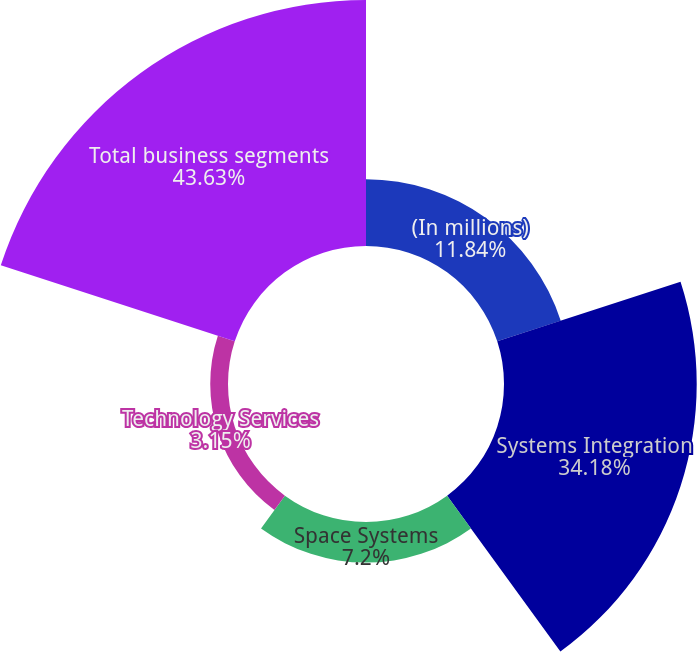<chart> <loc_0><loc_0><loc_500><loc_500><pie_chart><fcel>(In millions)<fcel>Systems Integration<fcel>Space Systems<fcel>Technology Services<fcel>Total business segments<nl><fcel>11.84%<fcel>34.18%<fcel>7.2%<fcel>3.15%<fcel>43.63%<nl></chart> 